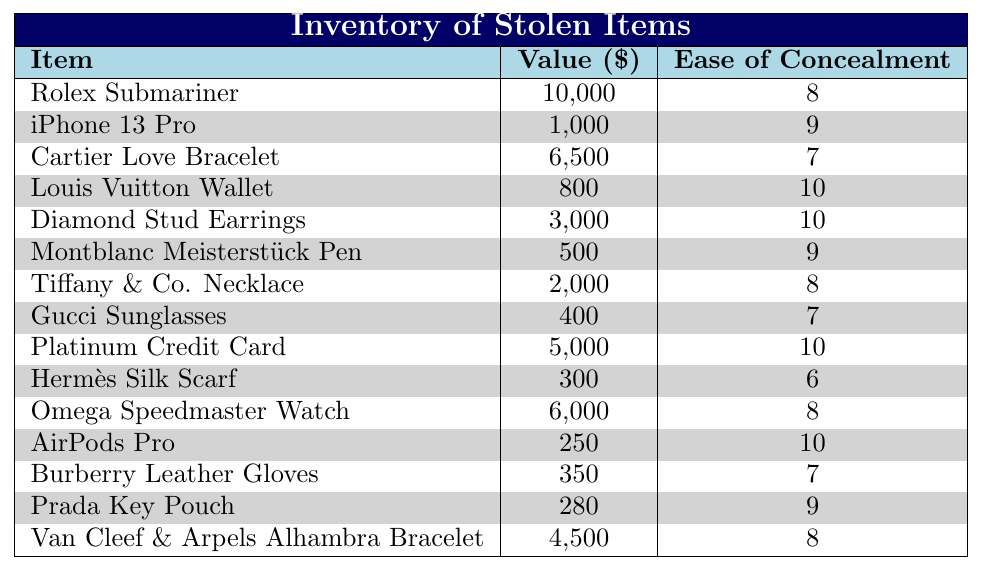What is the highest value item in the inventory? The highest value item listed is the Rolex Submariner, which is valued at $10,000.
Answer: Rolex Submariner Which item has the lowest ease of concealment? The item with the lowest ease of concealment is the Hermès Silk Scarf, which has an ease rating of 6.
Answer: Hermès Silk Scarf How many items are there with an ease of concealment rating of 10? There are 4 items with an ease of concealment rating of 10: Louis Vuitton Wallet, Diamond Stud Earrings, Platinum Credit Card, and AirPods Pro.
Answer: 4 What is the total value of all items listed in the inventory? The total value is calculated by summing all individual values: 10,000 + 1,000 + 6,500 + 800 + 3,000 + 500 + 2,000 + 400 + 5,000 + 300 + 6,000 + 250 + 350 + 280 + 4,500 = 40,880.
Answer: 40,880 Is there an item that has both high value and high ease of concealment? Yes, the Rolex Submariner has a high value of $10,000 and an ease of concealment rating of 8.
Answer: Yes What is the average value of items with an ease of concealment rating of 9? The items with an ease of concealment rating of 9 are the iPhone 13 Pro, Montblanc Meisterstück Pen, and Prada Key Pouch with values of 1,000, 500, and 280 respectively, summing to 1,780. The average is 1,780 divided by 3, which equals approximately 593.33.
Answer: 593.33 How many items have a value greater than $4,000? There are 3 items valued greater than $4,000: Rolex Submariner ($10,000), Cartier Love Bracelet ($6,500), and Omega Speedmaster Watch ($6,000).
Answer: 3 What is the difference in value between the most valuable item and the least valuable item? The most valuable item is the Rolex Submariner at $10,000 and the least valuable is the Prada Key Pouch at $280. The difference is 10,000 - 280 = 9,720.
Answer: 9,720 Which item has the highest ease of concealment among those below $1,000? The item with the highest ease of concealment below $1,000 is the Louis Vuitton Wallet at an ease rating of 10.
Answer: Louis Vuitton Wallet 